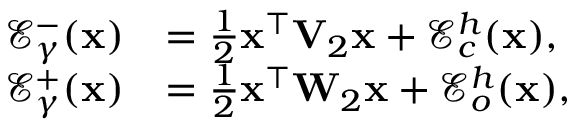Convert formula to latex. <formula><loc_0><loc_0><loc_500><loc_500>\begin{array} { r l } { \mathcal { E } _ { \gamma } ^ { - } ( x ) } & { = \frac { 1 } { 2 } x ^ { \top } V _ { 2 } x + \mathcal { E } _ { c } ^ { h } ( x ) , } \\ { \mathcal { E } _ { \gamma } ^ { + } ( x ) } & { = \frac { 1 } { 2 } x ^ { \top } W _ { 2 } x + \mathcal { E } _ { o } ^ { h } ( x ) , } \end{array}</formula> 